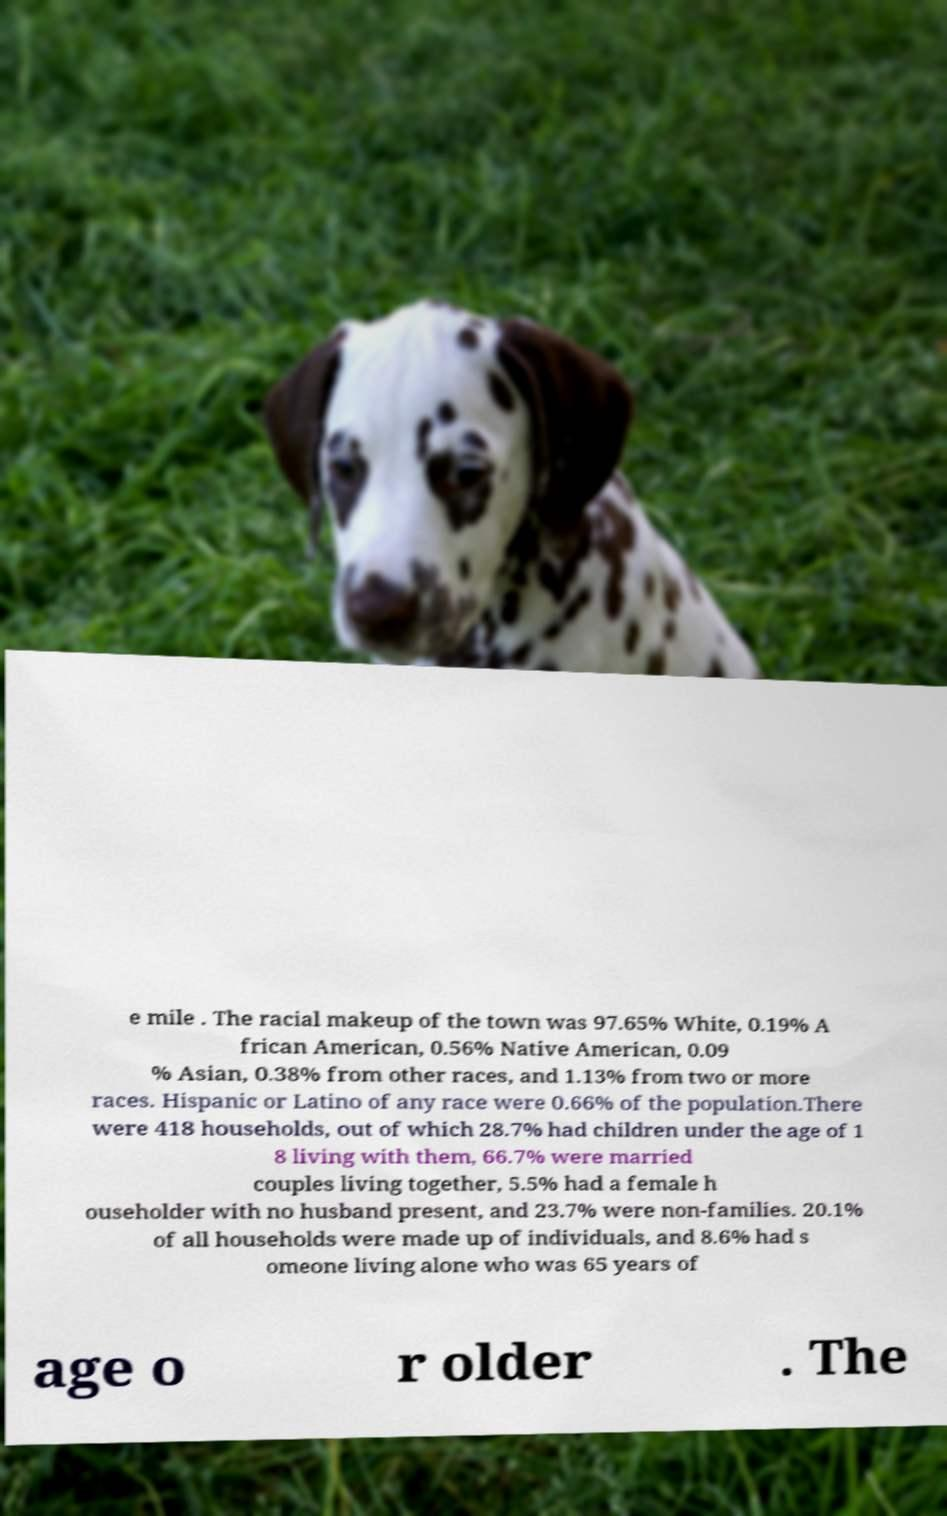Please identify and transcribe the text found in this image. e mile . The racial makeup of the town was 97.65% White, 0.19% A frican American, 0.56% Native American, 0.09 % Asian, 0.38% from other races, and 1.13% from two or more races. Hispanic or Latino of any race were 0.66% of the population.There were 418 households, out of which 28.7% had children under the age of 1 8 living with them, 66.7% were married couples living together, 5.5% had a female h ouseholder with no husband present, and 23.7% were non-families. 20.1% of all households were made up of individuals, and 8.6% had s omeone living alone who was 65 years of age o r older . The 